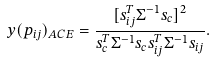<formula> <loc_0><loc_0><loc_500><loc_500>y ( p _ { i j } ) _ { A C E } = \frac { [ s _ { i j } ^ { T } \Sigma ^ { - 1 } s _ { c } ] ^ { 2 } } { s _ { c } ^ { T } \Sigma ^ { - 1 } s _ { c } s _ { i j } ^ { T } \Sigma ^ { - 1 } s _ { i j } } .</formula> 